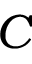<formula> <loc_0><loc_0><loc_500><loc_500>C</formula> 